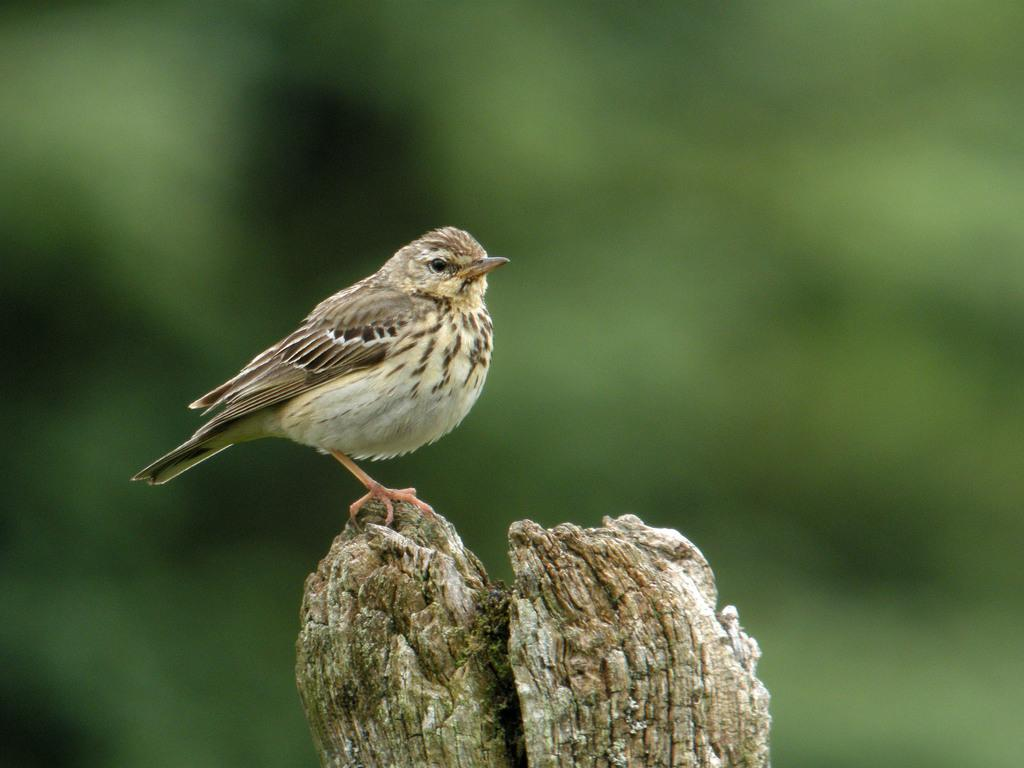What type of animal is present in the image? There is a bird in the image. What is the bird sitting on in the image? The bird is on a wooden object. Where in the image can the bird and the wooden object be found? The bird and the wooden object are visible at the bottom of the image. What type of design is featured on the bird's feathers in the image? There is no specific design mentioned on the bird's feathers in the provided facts. What type of dinner is being prepared in the image? There is no mention of dinner or cooking in the provided facts; the image only features a bird on a wooden object. 